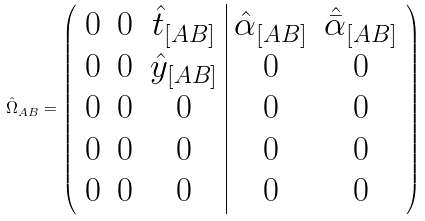Convert formula to latex. <formula><loc_0><loc_0><loc_500><loc_500>\hat { \Omega } _ { A B } = \left ( \begin{array} { c c c | c c } 0 & 0 & \hat { t } _ { [ A B ] } & \hat { \alpha } _ { [ A B ] } & \hat { \bar { \alpha } } _ { [ A B ] } \\ 0 & 0 & \hat { y } _ { [ A B ] } & 0 & 0 \\ 0 & 0 & 0 & 0 & 0 \\ 0 & 0 & 0 & 0 & 0 \\ 0 & 0 & 0 & 0 & 0 \end{array} \right )</formula> 